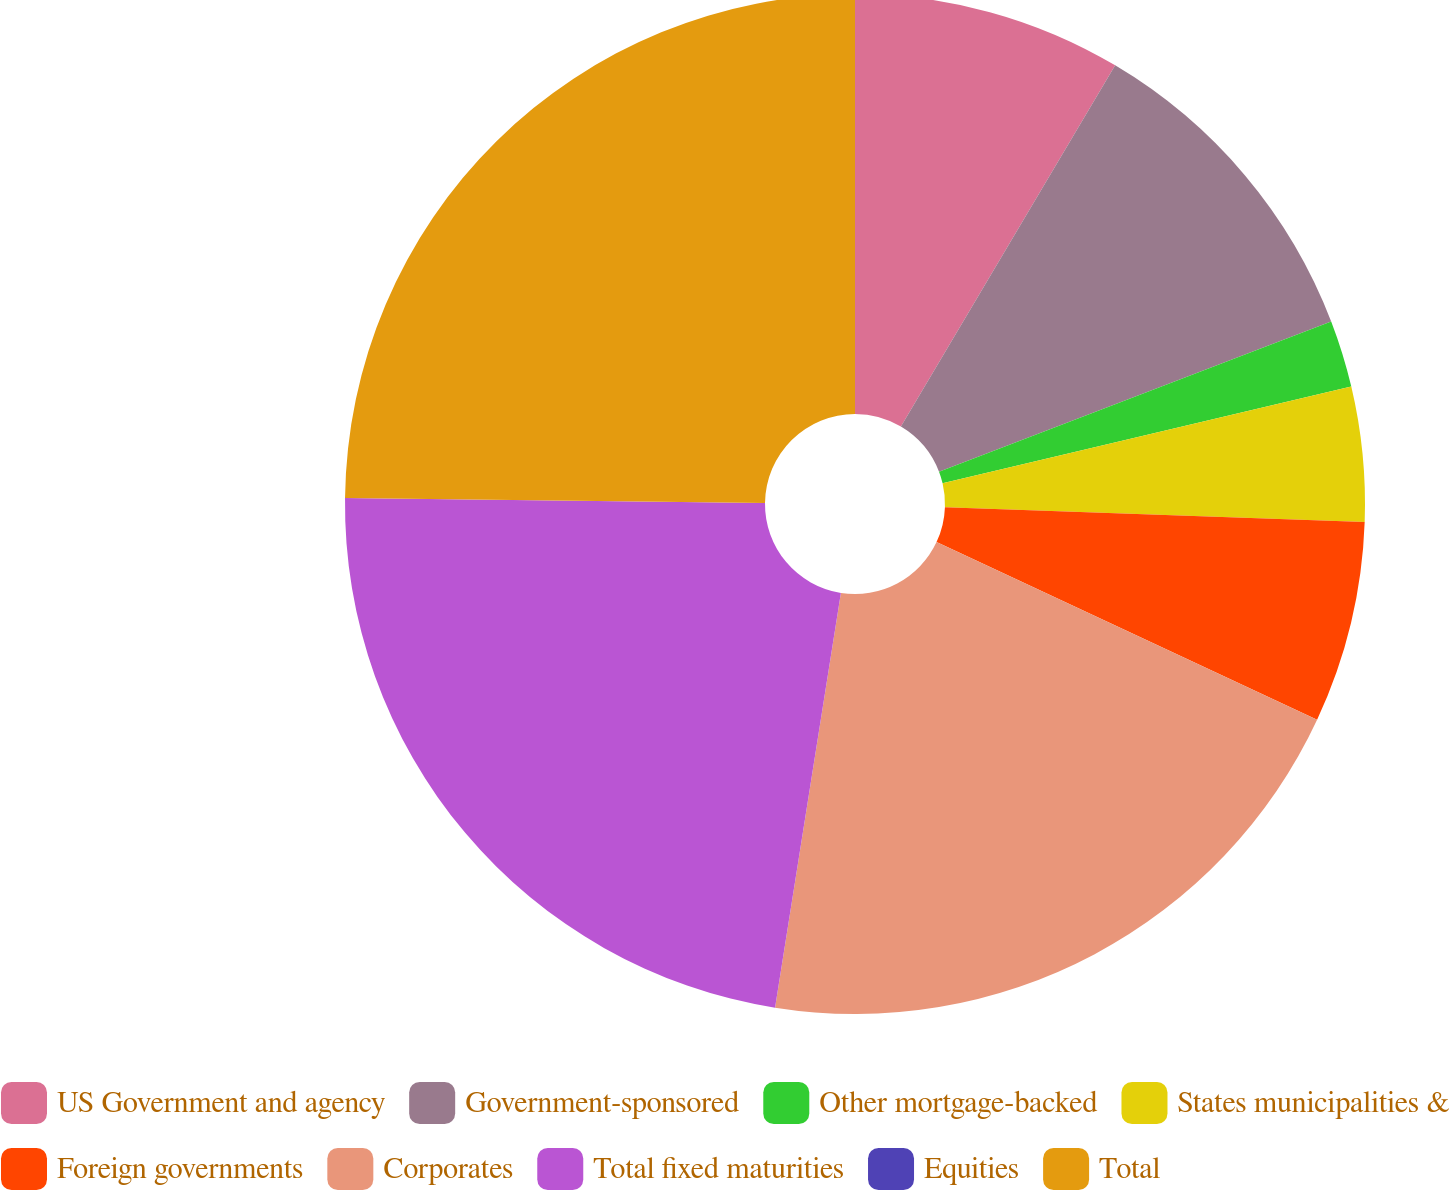Convert chart to OTSL. <chart><loc_0><loc_0><loc_500><loc_500><pie_chart><fcel>US Government and agency<fcel>Government-sponsored<fcel>Other mortgage-backed<fcel>States municipalities &<fcel>Foreign governments<fcel>Corporates<fcel>Total fixed maturities<fcel>Equities<fcel>Total<nl><fcel>8.52%<fcel>10.65%<fcel>2.13%<fcel>4.26%<fcel>6.39%<fcel>20.55%<fcel>22.68%<fcel>0.0%<fcel>24.81%<nl></chart> 